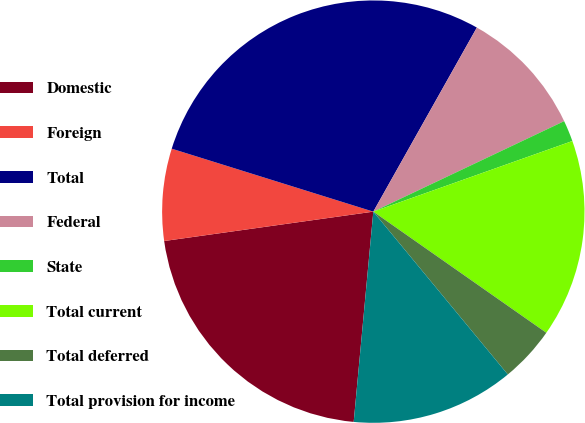Convert chart to OTSL. <chart><loc_0><loc_0><loc_500><loc_500><pie_chart><fcel>Domestic<fcel>Foreign<fcel>Total<fcel>Federal<fcel>State<fcel>Total current<fcel>Total deferred<fcel>Total provision for income<nl><fcel>21.3%<fcel>7.04%<fcel>28.34%<fcel>9.8%<fcel>1.62%<fcel>15.15%<fcel>4.29%<fcel>12.47%<nl></chart> 